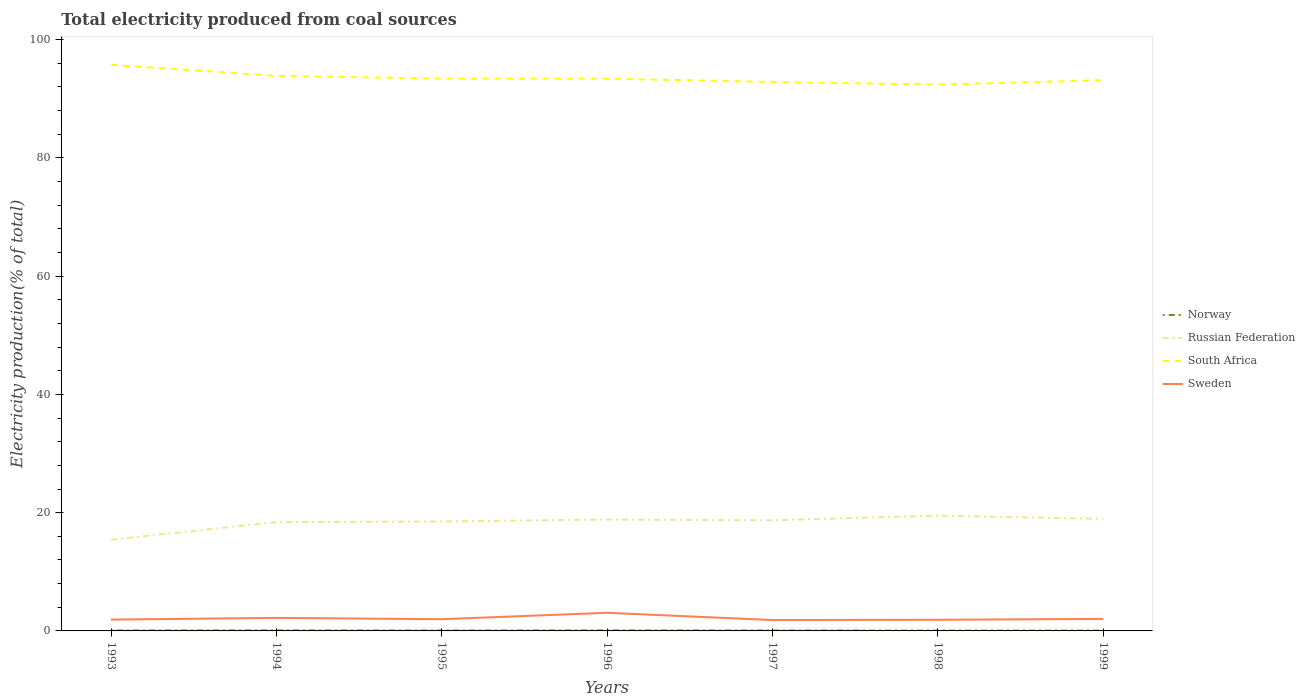How many different coloured lines are there?
Make the answer very short. 4. Does the line corresponding to Norway intersect with the line corresponding to Russian Federation?
Your response must be concise. No. Across all years, what is the maximum total electricity produced in Sweden?
Your answer should be compact. 1.84. What is the total total electricity produced in Russian Federation in the graph?
Your answer should be compact. -3.27. What is the difference between the highest and the second highest total electricity produced in South Africa?
Offer a terse response. 3.33. What is the difference between the highest and the lowest total electricity produced in South Africa?
Provide a short and direct response. 2. Is the total electricity produced in South Africa strictly greater than the total electricity produced in Sweden over the years?
Give a very brief answer. No. How many lines are there?
Give a very brief answer. 4. How many years are there in the graph?
Ensure brevity in your answer.  7. What is the difference between two consecutive major ticks on the Y-axis?
Provide a succinct answer. 20. Are the values on the major ticks of Y-axis written in scientific E-notation?
Ensure brevity in your answer.  No. Does the graph contain any zero values?
Give a very brief answer. No. Does the graph contain grids?
Your response must be concise. No. How are the legend labels stacked?
Provide a succinct answer. Vertical. What is the title of the graph?
Offer a very short reply. Total electricity produced from coal sources. Does "Sri Lanka" appear as one of the legend labels in the graph?
Offer a terse response. No. What is the label or title of the X-axis?
Provide a succinct answer. Years. What is the label or title of the Y-axis?
Give a very brief answer. Electricity production(% of total). What is the Electricity production(% of total) in Norway in 1993?
Ensure brevity in your answer.  0.07. What is the Electricity production(% of total) in Russian Federation in 1993?
Keep it short and to the point. 15.43. What is the Electricity production(% of total) of South Africa in 1993?
Offer a terse response. 95.73. What is the Electricity production(% of total) in Sweden in 1993?
Ensure brevity in your answer.  1.91. What is the Electricity production(% of total) of Norway in 1994?
Provide a succinct answer. 0.09. What is the Electricity production(% of total) in Russian Federation in 1994?
Give a very brief answer. 18.39. What is the Electricity production(% of total) of South Africa in 1994?
Your response must be concise. 93.86. What is the Electricity production(% of total) of Sweden in 1994?
Keep it short and to the point. 2.2. What is the Electricity production(% of total) in Norway in 1995?
Your response must be concise. 0.07. What is the Electricity production(% of total) in Russian Federation in 1995?
Give a very brief answer. 18.51. What is the Electricity production(% of total) of South Africa in 1995?
Give a very brief answer. 93.41. What is the Electricity production(% of total) in Sweden in 1995?
Your answer should be compact. 1.98. What is the Electricity production(% of total) in Norway in 1996?
Provide a succinct answer. 0.09. What is the Electricity production(% of total) in Russian Federation in 1996?
Make the answer very short. 18.83. What is the Electricity production(% of total) in South Africa in 1996?
Give a very brief answer. 93.41. What is the Electricity production(% of total) in Sweden in 1996?
Give a very brief answer. 3.07. What is the Electricity production(% of total) in Norway in 1997?
Make the answer very short. 0.07. What is the Electricity production(% of total) in Russian Federation in 1997?
Your answer should be very brief. 18.7. What is the Electricity production(% of total) in South Africa in 1997?
Make the answer very short. 92.84. What is the Electricity production(% of total) of Sweden in 1997?
Keep it short and to the point. 1.84. What is the Electricity production(% of total) in Norway in 1998?
Give a very brief answer. 0.07. What is the Electricity production(% of total) in Russian Federation in 1998?
Keep it short and to the point. 19.5. What is the Electricity production(% of total) in South Africa in 1998?
Ensure brevity in your answer.  92.4. What is the Electricity production(% of total) in Sweden in 1998?
Your answer should be compact. 1.88. What is the Electricity production(% of total) of Norway in 1999?
Give a very brief answer. 0.07. What is the Electricity production(% of total) of Russian Federation in 1999?
Your answer should be compact. 18.94. What is the Electricity production(% of total) in South Africa in 1999?
Your answer should be compact. 93.13. What is the Electricity production(% of total) of Sweden in 1999?
Give a very brief answer. 2.03. Across all years, what is the maximum Electricity production(% of total) in Norway?
Provide a short and direct response. 0.09. Across all years, what is the maximum Electricity production(% of total) of Russian Federation?
Make the answer very short. 19.5. Across all years, what is the maximum Electricity production(% of total) in South Africa?
Your answer should be very brief. 95.73. Across all years, what is the maximum Electricity production(% of total) in Sweden?
Make the answer very short. 3.07. Across all years, what is the minimum Electricity production(% of total) in Norway?
Keep it short and to the point. 0.07. Across all years, what is the minimum Electricity production(% of total) in Russian Federation?
Your response must be concise. 15.43. Across all years, what is the minimum Electricity production(% of total) in South Africa?
Offer a terse response. 92.4. Across all years, what is the minimum Electricity production(% of total) of Sweden?
Keep it short and to the point. 1.84. What is the total Electricity production(% of total) of Norway in the graph?
Offer a very short reply. 0.53. What is the total Electricity production(% of total) of Russian Federation in the graph?
Give a very brief answer. 128.31. What is the total Electricity production(% of total) of South Africa in the graph?
Give a very brief answer. 654.77. What is the total Electricity production(% of total) of Sweden in the graph?
Provide a short and direct response. 14.92. What is the difference between the Electricity production(% of total) in Norway in 1993 and that in 1994?
Provide a short and direct response. -0.01. What is the difference between the Electricity production(% of total) in Russian Federation in 1993 and that in 1994?
Offer a terse response. -2.96. What is the difference between the Electricity production(% of total) in South Africa in 1993 and that in 1994?
Offer a very short reply. 1.87. What is the difference between the Electricity production(% of total) of Sweden in 1993 and that in 1994?
Provide a succinct answer. -0.29. What is the difference between the Electricity production(% of total) of Norway in 1993 and that in 1995?
Provide a succinct answer. 0. What is the difference between the Electricity production(% of total) of Russian Federation in 1993 and that in 1995?
Your answer should be compact. -3.08. What is the difference between the Electricity production(% of total) in South Africa in 1993 and that in 1995?
Offer a very short reply. 2.32. What is the difference between the Electricity production(% of total) of Sweden in 1993 and that in 1995?
Your response must be concise. -0.07. What is the difference between the Electricity production(% of total) in Norway in 1993 and that in 1996?
Offer a very short reply. -0.01. What is the difference between the Electricity production(% of total) of Russian Federation in 1993 and that in 1996?
Keep it short and to the point. -3.4. What is the difference between the Electricity production(% of total) of South Africa in 1993 and that in 1996?
Offer a very short reply. 2.32. What is the difference between the Electricity production(% of total) of Sweden in 1993 and that in 1996?
Provide a succinct answer. -1.15. What is the difference between the Electricity production(% of total) in Norway in 1993 and that in 1997?
Keep it short and to the point. 0. What is the difference between the Electricity production(% of total) of Russian Federation in 1993 and that in 1997?
Make the answer very short. -3.27. What is the difference between the Electricity production(% of total) in South Africa in 1993 and that in 1997?
Offer a terse response. 2.9. What is the difference between the Electricity production(% of total) of Sweden in 1993 and that in 1997?
Provide a short and direct response. 0.07. What is the difference between the Electricity production(% of total) in Norway in 1993 and that in 1998?
Provide a short and direct response. 0.01. What is the difference between the Electricity production(% of total) of Russian Federation in 1993 and that in 1998?
Your response must be concise. -4.07. What is the difference between the Electricity production(% of total) of South Africa in 1993 and that in 1998?
Your response must be concise. 3.33. What is the difference between the Electricity production(% of total) of Sweden in 1993 and that in 1998?
Give a very brief answer. 0.03. What is the difference between the Electricity production(% of total) of Norway in 1993 and that in 1999?
Offer a terse response. 0.01. What is the difference between the Electricity production(% of total) in Russian Federation in 1993 and that in 1999?
Your answer should be compact. -3.51. What is the difference between the Electricity production(% of total) of South Africa in 1993 and that in 1999?
Keep it short and to the point. 2.6. What is the difference between the Electricity production(% of total) in Sweden in 1993 and that in 1999?
Ensure brevity in your answer.  -0.12. What is the difference between the Electricity production(% of total) of Norway in 1994 and that in 1995?
Keep it short and to the point. 0.02. What is the difference between the Electricity production(% of total) in Russian Federation in 1994 and that in 1995?
Your response must be concise. -0.12. What is the difference between the Electricity production(% of total) in South Africa in 1994 and that in 1995?
Provide a short and direct response. 0.45. What is the difference between the Electricity production(% of total) of Sweden in 1994 and that in 1995?
Make the answer very short. 0.22. What is the difference between the Electricity production(% of total) of Norway in 1994 and that in 1996?
Offer a terse response. 0. What is the difference between the Electricity production(% of total) in Russian Federation in 1994 and that in 1996?
Provide a succinct answer. -0.44. What is the difference between the Electricity production(% of total) in South Africa in 1994 and that in 1996?
Make the answer very short. 0.46. What is the difference between the Electricity production(% of total) in Sweden in 1994 and that in 1996?
Make the answer very short. -0.86. What is the difference between the Electricity production(% of total) of Norway in 1994 and that in 1997?
Ensure brevity in your answer.  0.02. What is the difference between the Electricity production(% of total) in Russian Federation in 1994 and that in 1997?
Provide a short and direct response. -0.31. What is the difference between the Electricity production(% of total) in South Africa in 1994 and that in 1997?
Your response must be concise. 1.03. What is the difference between the Electricity production(% of total) in Sweden in 1994 and that in 1997?
Ensure brevity in your answer.  0.37. What is the difference between the Electricity production(% of total) in Norway in 1994 and that in 1998?
Ensure brevity in your answer.  0.02. What is the difference between the Electricity production(% of total) of Russian Federation in 1994 and that in 1998?
Your response must be concise. -1.11. What is the difference between the Electricity production(% of total) in South Africa in 1994 and that in 1998?
Offer a very short reply. 1.46. What is the difference between the Electricity production(% of total) of Sweden in 1994 and that in 1998?
Provide a short and direct response. 0.32. What is the difference between the Electricity production(% of total) in Norway in 1994 and that in 1999?
Provide a succinct answer. 0.02. What is the difference between the Electricity production(% of total) of Russian Federation in 1994 and that in 1999?
Your response must be concise. -0.55. What is the difference between the Electricity production(% of total) in South Africa in 1994 and that in 1999?
Provide a succinct answer. 0.73. What is the difference between the Electricity production(% of total) in Sweden in 1994 and that in 1999?
Provide a short and direct response. 0.18. What is the difference between the Electricity production(% of total) of Norway in 1995 and that in 1996?
Provide a short and direct response. -0.02. What is the difference between the Electricity production(% of total) in Russian Federation in 1995 and that in 1996?
Provide a short and direct response. -0.32. What is the difference between the Electricity production(% of total) in South Africa in 1995 and that in 1996?
Your answer should be compact. 0. What is the difference between the Electricity production(% of total) of Sweden in 1995 and that in 1996?
Ensure brevity in your answer.  -1.08. What is the difference between the Electricity production(% of total) in Norway in 1995 and that in 1997?
Keep it short and to the point. -0. What is the difference between the Electricity production(% of total) of Russian Federation in 1995 and that in 1997?
Keep it short and to the point. -0.19. What is the difference between the Electricity production(% of total) of South Africa in 1995 and that in 1997?
Make the answer very short. 0.57. What is the difference between the Electricity production(% of total) in Sweden in 1995 and that in 1997?
Give a very brief answer. 0.14. What is the difference between the Electricity production(% of total) of Norway in 1995 and that in 1998?
Provide a short and direct response. 0. What is the difference between the Electricity production(% of total) of Russian Federation in 1995 and that in 1998?
Offer a very short reply. -0.99. What is the difference between the Electricity production(% of total) in South Africa in 1995 and that in 1998?
Your answer should be compact. 1.01. What is the difference between the Electricity production(% of total) in Sweden in 1995 and that in 1998?
Offer a terse response. 0.1. What is the difference between the Electricity production(% of total) in Norway in 1995 and that in 1999?
Offer a terse response. 0. What is the difference between the Electricity production(% of total) of Russian Federation in 1995 and that in 1999?
Your response must be concise. -0.43. What is the difference between the Electricity production(% of total) in South Africa in 1995 and that in 1999?
Your response must be concise. 0.27. What is the difference between the Electricity production(% of total) in Sweden in 1995 and that in 1999?
Offer a very short reply. -0.05. What is the difference between the Electricity production(% of total) of Norway in 1996 and that in 1997?
Offer a very short reply. 0.01. What is the difference between the Electricity production(% of total) in Russian Federation in 1996 and that in 1997?
Offer a terse response. 0.13. What is the difference between the Electricity production(% of total) in South Africa in 1996 and that in 1997?
Your answer should be very brief. 0.57. What is the difference between the Electricity production(% of total) of Sweden in 1996 and that in 1997?
Your answer should be very brief. 1.23. What is the difference between the Electricity production(% of total) of Norway in 1996 and that in 1998?
Your response must be concise. 0.02. What is the difference between the Electricity production(% of total) of Russian Federation in 1996 and that in 1998?
Your answer should be compact. -0.67. What is the difference between the Electricity production(% of total) of South Africa in 1996 and that in 1998?
Offer a terse response. 1.01. What is the difference between the Electricity production(% of total) of Sweden in 1996 and that in 1998?
Give a very brief answer. 1.18. What is the difference between the Electricity production(% of total) in Norway in 1996 and that in 1999?
Offer a terse response. 0.02. What is the difference between the Electricity production(% of total) of Russian Federation in 1996 and that in 1999?
Ensure brevity in your answer.  -0.11. What is the difference between the Electricity production(% of total) in South Africa in 1996 and that in 1999?
Ensure brevity in your answer.  0.27. What is the difference between the Electricity production(% of total) of Sweden in 1996 and that in 1999?
Your answer should be very brief. 1.04. What is the difference between the Electricity production(% of total) in Norway in 1997 and that in 1998?
Give a very brief answer. 0. What is the difference between the Electricity production(% of total) of Russian Federation in 1997 and that in 1998?
Offer a very short reply. -0.79. What is the difference between the Electricity production(% of total) of South Africa in 1997 and that in 1998?
Give a very brief answer. 0.44. What is the difference between the Electricity production(% of total) in Sweden in 1997 and that in 1998?
Your answer should be very brief. -0.05. What is the difference between the Electricity production(% of total) in Norway in 1997 and that in 1999?
Your response must be concise. 0. What is the difference between the Electricity production(% of total) in Russian Federation in 1997 and that in 1999?
Ensure brevity in your answer.  -0.24. What is the difference between the Electricity production(% of total) in South Africa in 1997 and that in 1999?
Your answer should be very brief. -0.3. What is the difference between the Electricity production(% of total) in Sweden in 1997 and that in 1999?
Keep it short and to the point. -0.19. What is the difference between the Electricity production(% of total) in Norway in 1998 and that in 1999?
Your response must be concise. -0. What is the difference between the Electricity production(% of total) in Russian Federation in 1998 and that in 1999?
Offer a very short reply. 0.55. What is the difference between the Electricity production(% of total) of South Africa in 1998 and that in 1999?
Offer a terse response. -0.74. What is the difference between the Electricity production(% of total) of Sweden in 1998 and that in 1999?
Your response must be concise. -0.14. What is the difference between the Electricity production(% of total) of Norway in 1993 and the Electricity production(% of total) of Russian Federation in 1994?
Provide a short and direct response. -18.32. What is the difference between the Electricity production(% of total) of Norway in 1993 and the Electricity production(% of total) of South Africa in 1994?
Your answer should be very brief. -93.79. What is the difference between the Electricity production(% of total) in Norway in 1993 and the Electricity production(% of total) in Sweden in 1994?
Make the answer very short. -2.13. What is the difference between the Electricity production(% of total) in Russian Federation in 1993 and the Electricity production(% of total) in South Africa in 1994?
Make the answer very short. -78.43. What is the difference between the Electricity production(% of total) in Russian Federation in 1993 and the Electricity production(% of total) in Sweden in 1994?
Ensure brevity in your answer.  13.23. What is the difference between the Electricity production(% of total) of South Africa in 1993 and the Electricity production(% of total) of Sweden in 1994?
Provide a short and direct response. 93.53. What is the difference between the Electricity production(% of total) of Norway in 1993 and the Electricity production(% of total) of Russian Federation in 1995?
Give a very brief answer. -18.44. What is the difference between the Electricity production(% of total) of Norway in 1993 and the Electricity production(% of total) of South Africa in 1995?
Offer a very short reply. -93.33. What is the difference between the Electricity production(% of total) in Norway in 1993 and the Electricity production(% of total) in Sweden in 1995?
Give a very brief answer. -1.91. What is the difference between the Electricity production(% of total) in Russian Federation in 1993 and the Electricity production(% of total) in South Africa in 1995?
Make the answer very short. -77.97. What is the difference between the Electricity production(% of total) in Russian Federation in 1993 and the Electricity production(% of total) in Sweden in 1995?
Give a very brief answer. 13.45. What is the difference between the Electricity production(% of total) in South Africa in 1993 and the Electricity production(% of total) in Sweden in 1995?
Your answer should be very brief. 93.75. What is the difference between the Electricity production(% of total) of Norway in 1993 and the Electricity production(% of total) of Russian Federation in 1996?
Your answer should be very brief. -18.76. What is the difference between the Electricity production(% of total) of Norway in 1993 and the Electricity production(% of total) of South Africa in 1996?
Make the answer very short. -93.33. What is the difference between the Electricity production(% of total) in Norway in 1993 and the Electricity production(% of total) in Sweden in 1996?
Your answer should be very brief. -2.99. What is the difference between the Electricity production(% of total) of Russian Federation in 1993 and the Electricity production(% of total) of South Africa in 1996?
Provide a short and direct response. -77.97. What is the difference between the Electricity production(% of total) in Russian Federation in 1993 and the Electricity production(% of total) in Sweden in 1996?
Provide a short and direct response. 12.37. What is the difference between the Electricity production(% of total) in South Africa in 1993 and the Electricity production(% of total) in Sweden in 1996?
Your answer should be very brief. 92.66. What is the difference between the Electricity production(% of total) in Norway in 1993 and the Electricity production(% of total) in Russian Federation in 1997?
Your answer should be compact. -18.63. What is the difference between the Electricity production(% of total) in Norway in 1993 and the Electricity production(% of total) in South Africa in 1997?
Offer a terse response. -92.76. What is the difference between the Electricity production(% of total) of Norway in 1993 and the Electricity production(% of total) of Sweden in 1997?
Make the answer very short. -1.76. What is the difference between the Electricity production(% of total) in Russian Federation in 1993 and the Electricity production(% of total) in South Africa in 1997?
Make the answer very short. -77.4. What is the difference between the Electricity production(% of total) of Russian Federation in 1993 and the Electricity production(% of total) of Sweden in 1997?
Offer a very short reply. 13.59. What is the difference between the Electricity production(% of total) of South Africa in 1993 and the Electricity production(% of total) of Sweden in 1997?
Offer a very short reply. 93.89. What is the difference between the Electricity production(% of total) in Norway in 1993 and the Electricity production(% of total) in Russian Federation in 1998?
Provide a short and direct response. -19.42. What is the difference between the Electricity production(% of total) of Norway in 1993 and the Electricity production(% of total) of South Africa in 1998?
Give a very brief answer. -92.32. What is the difference between the Electricity production(% of total) of Norway in 1993 and the Electricity production(% of total) of Sweden in 1998?
Your response must be concise. -1.81. What is the difference between the Electricity production(% of total) of Russian Federation in 1993 and the Electricity production(% of total) of South Africa in 1998?
Your answer should be compact. -76.97. What is the difference between the Electricity production(% of total) in Russian Federation in 1993 and the Electricity production(% of total) in Sweden in 1998?
Your answer should be very brief. 13.55. What is the difference between the Electricity production(% of total) in South Africa in 1993 and the Electricity production(% of total) in Sweden in 1998?
Offer a terse response. 93.85. What is the difference between the Electricity production(% of total) in Norway in 1993 and the Electricity production(% of total) in Russian Federation in 1999?
Provide a short and direct response. -18.87. What is the difference between the Electricity production(% of total) of Norway in 1993 and the Electricity production(% of total) of South Africa in 1999?
Your answer should be compact. -93.06. What is the difference between the Electricity production(% of total) in Norway in 1993 and the Electricity production(% of total) in Sweden in 1999?
Provide a short and direct response. -1.95. What is the difference between the Electricity production(% of total) of Russian Federation in 1993 and the Electricity production(% of total) of South Africa in 1999?
Your answer should be compact. -77.7. What is the difference between the Electricity production(% of total) in Russian Federation in 1993 and the Electricity production(% of total) in Sweden in 1999?
Give a very brief answer. 13.4. What is the difference between the Electricity production(% of total) of South Africa in 1993 and the Electricity production(% of total) of Sweden in 1999?
Your answer should be compact. 93.7. What is the difference between the Electricity production(% of total) of Norway in 1994 and the Electricity production(% of total) of Russian Federation in 1995?
Offer a very short reply. -18.42. What is the difference between the Electricity production(% of total) of Norway in 1994 and the Electricity production(% of total) of South Africa in 1995?
Offer a terse response. -93.32. What is the difference between the Electricity production(% of total) of Norway in 1994 and the Electricity production(% of total) of Sweden in 1995?
Offer a very short reply. -1.89. What is the difference between the Electricity production(% of total) in Russian Federation in 1994 and the Electricity production(% of total) in South Africa in 1995?
Provide a succinct answer. -75.02. What is the difference between the Electricity production(% of total) of Russian Federation in 1994 and the Electricity production(% of total) of Sweden in 1995?
Ensure brevity in your answer.  16.41. What is the difference between the Electricity production(% of total) in South Africa in 1994 and the Electricity production(% of total) in Sweden in 1995?
Make the answer very short. 91.88. What is the difference between the Electricity production(% of total) in Norway in 1994 and the Electricity production(% of total) in Russian Federation in 1996?
Provide a succinct answer. -18.74. What is the difference between the Electricity production(% of total) in Norway in 1994 and the Electricity production(% of total) in South Africa in 1996?
Your answer should be very brief. -93.32. What is the difference between the Electricity production(% of total) in Norway in 1994 and the Electricity production(% of total) in Sweden in 1996?
Ensure brevity in your answer.  -2.98. What is the difference between the Electricity production(% of total) in Russian Federation in 1994 and the Electricity production(% of total) in South Africa in 1996?
Provide a short and direct response. -75.02. What is the difference between the Electricity production(% of total) in Russian Federation in 1994 and the Electricity production(% of total) in Sweden in 1996?
Provide a succinct answer. 15.32. What is the difference between the Electricity production(% of total) of South Africa in 1994 and the Electricity production(% of total) of Sweden in 1996?
Provide a succinct answer. 90.8. What is the difference between the Electricity production(% of total) in Norway in 1994 and the Electricity production(% of total) in Russian Federation in 1997?
Provide a short and direct response. -18.62. What is the difference between the Electricity production(% of total) in Norway in 1994 and the Electricity production(% of total) in South Africa in 1997?
Your answer should be compact. -92.75. What is the difference between the Electricity production(% of total) of Norway in 1994 and the Electricity production(% of total) of Sweden in 1997?
Your response must be concise. -1.75. What is the difference between the Electricity production(% of total) in Russian Federation in 1994 and the Electricity production(% of total) in South Africa in 1997?
Provide a short and direct response. -74.44. What is the difference between the Electricity production(% of total) in Russian Federation in 1994 and the Electricity production(% of total) in Sweden in 1997?
Give a very brief answer. 16.55. What is the difference between the Electricity production(% of total) in South Africa in 1994 and the Electricity production(% of total) in Sweden in 1997?
Provide a short and direct response. 92.02. What is the difference between the Electricity production(% of total) of Norway in 1994 and the Electricity production(% of total) of Russian Federation in 1998?
Give a very brief answer. -19.41. What is the difference between the Electricity production(% of total) in Norway in 1994 and the Electricity production(% of total) in South Africa in 1998?
Provide a short and direct response. -92.31. What is the difference between the Electricity production(% of total) of Norway in 1994 and the Electricity production(% of total) of Sweden in 1998?
Make the answer very short. -1.8. What is the difference between the Electricity production(% of total) of Russian Federation in 1994 and the Electricity production(% of total) of South Africa in 1998?
Provide a short and direct response. -74.01. What is the difference between the Electricity production(% of total) in Russian Federation in 1994 and the Electricity production(% of total) in Sweden in 1998?
Your answer should be compact. 16.51. What is the difference between the Electricity production(% of total) of South Africa in 1994 and the Electricity production(% of total) of Sweden in 1998?
Your response must be concise. 91.98. What is the difference between the Electricity production(% of total) of Norway in 1994 and the Electricity production(% of total) of Russian Federation in 1999?
Provide a short and direct response. -18.86. What is the difference between the Electricity production(% of total) of Norway in 1994 and the Electricity production(% of total) of South Africa in 1999?
Ensure brevity in your answer.  -93.05. What is the difference between the Electricity production(% of total) of Norway in 1994 and the Electricity production(% of total) of Sweden in 1999?
Make the answer very short. -1.94. What is the difference between the Electricity production(% of total) in Russian Federation in 1994 and the Electricity production(% of total) in South Africa in 1999?
Give a very brief answer. -74.74. What is the difference between the Electricity production(% of total) of Russian Federation in 1994 and the Electricity production(% of total) of Sweden in 1999?
Make the answer very short. 16.36. What is the difference between the Electricity production(% of total) in South Africa in 1994 and the Electricity production(% of total) in Sweden in 1999?
Ensure brevity in your answer.  91.83. What is the difference between the Electricity production(% of total) in Norway in 1995 and the Electricity production(% of total) in Russian Federation in 1996?
Ensure brevity in your answer.  -18.76. What is the difference between the Electricity production(% of total) in Norway in 1995 and the Electricity production(% of total) in South Africa in 1996?
Give a very brief answer. -93.34. What is the difference between the Electricity production(% of total) in Norway in 1995 and the Electricity production(% of total) in Sweden in 1996?
Offer a very short reply. -3. What is the difference between the Electricity production(% of total) in Russian Federation in 1995 and the Electricity production(% of total) in South Africa in 1996?
Keep it short and to the point. -74.89. What is the difference between the Electricity production(% of total) of Russian Federation in 1995 and the Electricity production(% of total) of Sweden in 1996?
Give a very brief answer. 15.45. What is the difference between the Electricity production(% of total) of South Africa in 1995 and the Electricity production(% of total) of Sweden in 1996?
Ensure brevity in your answer.  90.34. What is the difference between the Electricity production(% of total) of Norway in 1995 and the Electricity production(% of total) of Russian Federation in 1997?
Your answer should be compact. -18.63. What is the difference between the Electricity production(% of total) of Norway in 1995 and the Electricity production(% of total) of South Africa in 1997?
Provide a short and direct response. -92.77. What is the difference between the Electricity production(% of total) of Norway in 1995 and the Electricity production(% of total) of Sweden in 1997?
Provide a short and direct response. -1.77. What is the difference between the Electricity production(% of total) of Russian Federation in 1995 and the Electricity production(% of total) of South Africa in 1997?
Your answer should be very brief. -74.32. What is the difference between the Electricity production(% of total) in Russian Federation in 1995 and the Electricity production(% of total) in Sweden in 1997?
Offer a very short reply. 16.67. What is the difference between the Electricity production(% of total) of South Africa in 1995 and the Electricity production(% of total) of Sweden in 1997?
Keep it short and to the point. 91.57. What is the difference between the Electricity production(% of total) in Norway in 1995 and the Electricity production(% of total) in Russian Federation in 1998?
Ensure brevity in your answer.  -19.43. What is the difference between the Electricity production(% of total) of Norway in 1995 and the Electricity production(% of total) of South Africa in 1998?
Offer a terse response. -92.33. What is the difference between the Electricity production(% of total) in Norway in 1995 and the Electricity production(% of total) in Sweden in 1998?
Your answer should be very brief. -1.81. What is the difference between the Electricity production(% of total) in Russian Federation in 1995 and the Electricity production(% of total) in South Africa in 1998?
Give a very brief answer. -73.89. What is the difference between the Electricity production(% of total) in Russian Federation in 1995 and the Electricity production(% of total) in Sweden in 1998?
Your answer should be compact. 16.63. What is the difference between the Electricity production(% of total) of South Africa in 1995 and the Electricity production(% of total) of Sweden in 1998?
Your response must be concise. 91.52. What is the difference between the Electricity production(% of total) in Norway in 1995 and the Electricity production(% of total) in Russian Federation in 1999?
Make the answer very short. -18.88. What is the difference between the Electricity production(% of total) of Norway in 1995 and the Electricity production(% of total) of South Africa in 1999?
Ensure brevity in your answer.  -93.06. What is the difference between the Electricity production(% of total) of Norway in 1995 and the Electricity production(% of total) of Sweden in 1999?
Offer a terse response. -1.96. What is the difference between the Electricity production(% of total) of Russian Federation in 1995 and the Electricity production(% of total) of South Africa in 1999?
Make the answer very short. -74.62. What is the difference between the Electricity production(% of total) in Russian Federation in 1995 and the Electricity production(% of total) in Sweden in 1999?
Offer a very short reply. 16.48. What is the difference between the Electricity production(% of total) in South Africa in 1995 and the Electricity production(% of total) in Sweden in 1999?
Your answer should be very brief. 91.38. What is the difference between the Electricity production(% of total) in Norway in 1996 and the Electricity production(% of total) in Russian Federation in 1997?
Provide a succinct answer. -18.62. What is the difference between the Electricity production(% of total) of Norway in 1996 and the Electricity production(% of total) of South Africa in 1997?
Give a very brief answer. -92.75. What is the difference between the Electricity production(% of total) of Norway in 1996 and the Electricity production(% of total) of Sweden in 1997?
Ensure brevity in your answer.  -1.75. What is the difference between the Electricity production(% of total) of Russian Federation in 1996 and the Electricity production(% of total) of South Africa in 1997?
Offer a terse response. -74. What is the difference between the Electricity production(% of total) in Russian Federation in 1996 and the Electricity production(% of total) in Sweden in 1997?
Your answer should be compact. 16.99. What is the difference between the Electricity production(% of total) in South Africa in 1996 and the Electricity production(% of total) in Sweden in 1997?
Your answer should be compact. 91.57. What is the difference between the Electricity production(% of total) of Norway in 1996 and the Electricity production(% of total) of Russian Federation in 1998?
Make the answer very short. -19.41. What is the difference between the Electricity production(% of total) of Norway in 1996 and the Electricity production(% of total) of South Africa in 1998?
Your answer should be very brief. -92.31. What is the difference between the Electricity production(% of total) in Norway in 1996 and the Electricity production(% of total) in Sweden in 1998?
Provide a short and direct response. -1.8. What is the difference between the Electricity production(% of total) of Russian Federation in 1996 and the Electricity production(% of total) of South Africa in 1998?
Offer a very short reply. -73.57. What is the difference between the Electricity production(% of total) in Russian Federation in 1996 and the Electricity production(% of total) in Sweden in 1998?
Provide a short and direct response. 16.95. What is the difference between the Electricity production(% of total) in South Africa in 1996 and the Electricity production(% of total) in Sweden in 1998?
Your response must be concise. 91.52. What is the difference between the Electricity production(% of total) of Norway in 1996 and the Electricity production(% of total) of Russian Federation in 1999?
Give a very brief answer. -18.86. What is the difference between the Electricity production(% of total) in Norway in 1996 and the Electricity production(% of total) in South Africa in 1999?
Your answer should be very brief. -93.05. What is the difference between the Electricity production(% of total) of Norway in 1996 and the Electricity production(% of total) of Sweden in 1999?
Ensure brevity in your answer.  -1.94. What is the difference between the Electricity production(% of total) of Russian Federation in 1996 and the Electricity production(% of total) of South Africa in 1999?
Offer a terse response. -74.3. What is the difference between the Electricity production(% of total) in Russian Federation in 1996 and the Electricity production(% of total) in Sweden in 1999?
Offer a terse response. 16.8. What is the difference between the Electricity production(% of total) of South Africa in 1996 and the Electricity production(% of total) of Sweden in 1999?
Offer a very short reply. 91.38. What is the difference between the Electricity production(% of total) of Norway in 1997 and the Electricity production(% of total) of Russian Federation in 1998?
Keep it short and to the point. -19.43. What is the difference between the Electricity production(% of total) in Norway in 1997 and the Electricity production(% of total) in South Africa in 1998?
Provide a short and direct response. -92.33. What is the difference between the Electricity production(% of total) in Norway in 1997 and the Electricity production(% of total) in Sweden in 1998?
Provide a succinct answer. -1.81. What is the difference between the Electricity production(% of total) of Russian Federation in 1997 and the Electricity production(% of total) of South Africa in 1998?
Your answer should be very brief. -73.69. What is the difference between the Electricity production(% of total) in Russian Federation in 1997 and the Electricity production(% of total) in Sweden in 1998?
Ensure brevity in your answer.  16.82. What is the difference between the Electricity production(% of total) in South Africa in 1997 and the Electricity production(% of total) in Sweden in 1998?
Give a very brief answer. 90.95. What is the difference between the Electricity production(% of total) in Norway in 1997 and the Electricity production(% of total) in Russian Federation in 1999?
Keep it short and to the point. -18.87. What is the difference between the Electricity production(% of total) in Norway in 1997 and the Electricity production(% of total) in South Africa in 1999?
Your answer should be compact. -93.06. What is the difference between the Electricity production(% of total) in Norway in 1997 and the Electricity production(% of total) in Sweden in 1999?
Offer a terse response. -1.96. What is the difference between the Electricity production(% of total) in Russian Federation in 1997 and the Electricity production(% of total) in South Africa in 1999?
Your answer should be compact. -74.43. What is the difference between the Electricity production(% of total) of Russian Federation in 1997 and the Electricity production(% of total) of Sweden in 1999?
Make the answer very short. 16.68. What is the difference between the Electricity production(% of total) in South Africa in 1997 and the Electricity production(% of total) in Sweden in 1999?
Your answer should be very brief. 90.81. What is the difference between the Electricity production(% of total) of Norway in 1998 and the Electricity production(% of total) of Russian Federation in 1999?
Ensure brevity in your answer.  -18.88. What is the difference between the Electricity production(% of total) of Norway in 1998 and the Electricity production(% of total) of South Africa in 1999?
Make the answer very short. -93.07. What is the difference between the Electricity production(% of total) of Norway in 1998 and the Electricity production(% of total) of Sweden in 1999?
Offer a very short reply. -1.96. What is the difference between the Electricity production(% of total) of Russian Federation in 1998 and the Electricity production(% of total) of South Africa in 1999?
Keep it short and to the point. -73.64. What is the difference between the Electricity production(% of total) of Russian Federation in 1998 and the Electricity production(% of total) of Sweden in 1999?
Offer a terse response. 17.47. What is the difference between the Electricity production(% of total) of South Africa in 1998 and the Electricity production(% of total) of Sweden in 1999?
Offer a very short reply. 90.37. What is the average Electricity production(% of total) in Norway per year?
Ensure brevity in your answer.  0.08. What is the average Electricity production(% of total) in Russian Federation per year?
Offer a terse response. 18.33. What is the average Electricity production(% of total) in South Africa per year?
Offer a very short reply. 93.54. What is the average Electricity production(% of total) in Sweden per year?
Your response must be concise. 2.13. In the year 1993, what is the difference between the Electricity production(% of total) in Norway and Electricity production(% of total) in Russian Federation?
Give a very brief answer. -15.36. In the year 1993, what is the difference between the Electricity production(% of total) in Norway and Electricity production(% of total) in South Africa?
Offer a terse response. -95.66. In the year 1993, what is the difference between the Electricity production(% of total) of Norway and Electricity production(% of total) of Sweden?
Offer a terse response. -1.84. In the year 1993, what is the difference between the Electricity production(% of total) of Russian Federation and Electricity production(% of total) of South Africa?
Your response must be concise. -80.3. In the year 1993, what is the difference between the Electricity production(% of total) in Russian Federation and Electricity production(% of total) in Sweden?
Make the answer very short. 13.52. In the year 1993, what is the difference between the Electricity production(% of total) of South Africa and Electricity production(% of total) of Sweden?
Offer a very short reply. 93.82. In the year 1994, what is the difference between the Electricity production(% of total) in Norway and Electricity production(% of total) in Russian Federation?
Keep it short and to the point. -18.3. In the year 1994, what is the difference between the Electricity production(% of total) of Norway and Electricity production(% of total) of South Africa?
Keep it short and to the point. -93.77. In the year 1994, what is the difference between the Electricity production(% of total) in Norway and Electricity production(% of total) in Sweden?
Provide a succinct answer. -2.12. In the year 1994, what is the difference between the Electricity production(% of total) of Russian Federation and Electricity production(% of total) of South Africa?
Your response must be concise. -75.47. In the year 1994, what is the difference between the Electricity production(% of total) of Russian Federation and Electricity production(% of total) of Sweden?
Offer a terse response. 16.19. In the year 1994, what is the difference between the Electricity production(% of total) of South Africa and Electricity production(% of total) of Sweden?
Make the answer very short. 91.66. In the year 1995, what is the difference between the Electricity production(% of total) of Norway and Electricity production(% of total) of Russian Federation?
Give a very brief answer. -18.44. In the year 1995, what is the difference between the Electricity production(% of total) of Norway and Electricity production(% of total) of South Africa?
Make the answer very short. -93.34. In the year 1995, what is the difference between the Electricity production(% of total) in Norway and Electricity production(% of total) in Sweden?
Keep it short and to the point. -1.91. In the year 1995, what is the difference between the Electricity production(% of total) of Russian Federation and Electricity production(% of total) of South Africa?
Provide a short and direct response. -74.9. In the year 1995, what is the difference between the Electricity production(% of total) of Russian Federation and Electricity production(% of total) of Sweden?
Your answer should be very brief. 16.53. In the year 1995, what is the difference between the Electricity production(% of total) of South Africa and Electricity production(% of total) of Sweden?
Ensure brevity in your answer.  91.43. In the year 1996, what is the difference between the Electricity production(% of total) in Norway and Electricity production(% of total) in Russian Federation?
Your answer should be compact. -18.74. In the year 1996, what is the difference between the Electricity production(% of total) of Norway and Electricity production(% of total) of South Africa?
Give a very brief answer. -93.32. In the year 1996, what is the difference between the Electricity production(% of total) in Norway and Electricity production(% of total) in Sweden?
Provide a short and direct response. -2.98. In the year 1996, what is the difference between the Electricity production(% of total) of Russian Federation and Electricity production(% of total) of South Africa?
Ensure brevity in your answer.  -74.58. In the year 1996, what is the difference between the Electricity production(% of total) of Russian Federation and Electricity production(% of total) of Sweden?
Provide a succinct answer. 15.76. In the year 1996, what is the difference between the Electricity production(% of total) of South Africa and Electricity production(% of total) of Sweden?
Your answer should be compact. 90.34. In the year 1997, what is the difference between the Electricity production(% of total) in Norway and Electricity production(% of total) in Russian Federation?
Your response must be concise. -18.63. In the year 1997, what is the difference between the Electricity production(% of total) of Norway and Electricity production(% of total) of South Africa?
Offer a terse response. -92.76. In the year 1997, what is the difference between the Electricity production(% of total) in Norway and Electricity production(% of total) in Sweden?
Ensure brevity in your answer.  -1.77. In the year 1997, what is the difference between the Electricity production(% of total) of Russian Federation and Electricity production(% of total) of South Africa?
Provide a short and direct response. -74.13. In the year 1997, what is the difference between the Electricity production(% of total) of Russian Federation and Electricity production(% of total) of Sweden?
Offer a very short reply. 16.87. In the year 1997, what is the difference between the Electricity production(% of total) in South Africa and Electricity production(% of total) in Sweden?
Give a very brief answer. 91. In the year 1998, what is the difference between the Electricity production(% of total) of Norway and Electricity production(% of total) of Russian Federation?
Give a very brief answer. -19.43. In the year 1998, what is the difference between the Electricity production(% of total) of Norway and Electricity production(% of total) of South Africa?
Your answer should be compact. -92.33. In the year 1998, what is the difference between the Electricity production(% of total) of Norway and Electricity production(% of total) of Sweden?
Offer a very short reply. -1.82. In the year 1998, what is the difference between the Electricity production(% of total) of Russian Federation and Electricity production(% of total) of South Africa?
Your answer should be very brief. -72.9. In the year 1998, what is the difference between the Electricity production(% of total) of Russian Federation and Electricity production(% of total) of Sweden?
Provide a short and direct response. 17.62. In the year 1998, what is the difference between the Electricity production(% of total) in South Africa and Electricity production(% of total) in Sweden?
Your answer should be very brief. 90.52. In the year 1999, what is the difference between the Electricity production(% of total) in Norway and Electricity production(% of total) in Russian Federation?
Make the answer very short. -18.88. In the year 1999, what is the difference between the Electricity production(% of total) in Norway and Electricity production(% of total) in South Africa?
Your answer should be compact. -93.07. In the year 1999, what is the difference between the Electricity production(% of total) of Norway and Electricity production(% of total) of Sweden?
Keep it short and to the point. -1.96. In the year 1999, what is the difference between the Electricity production(% of total) of Russian Federation and Electricity production(% of total) of South Africa?
Ensure brevity in your answer.  -74.19. In the year 1999, what is the difference between the Electricity production(% of total) in Russian Federation and Electricity production(% of total) in Sweden?
Offer a terse response. 16.92. In the year 1999, what is the difference between the Electricity production(% of total) in South Africa and Electricity production(% of total) in Sweden?
Offer a very short reply. 91.11. What is the ratio of the Electricity production(% of total) in Norway in 1993 to that in 1994?
Offer a terse response. 0.84. What is the ratio of the Electricity production(% of total) in Russian Federation in 1993 to that in 1994?
Ensure brevity in your answer.  0.84. What is the ratio of the Electricity production(% of total) of South Africa in 1993 to that in 1994?
Keep it short and to the point. 1.02. What is the ratio of the Electricity production(% of total) in Sweden in 1993 to that in 1994?
Your answer should be very brief. 0.87. What is the ratio of the Electricity production(% of total) in Norway in 1993 to that in 1995?
Provide a succinct answer. 1.07. What is the ratio of the Electricity production(% of total) of Russian Federation in 1993 to that in 1995?
Provide a short and direct response. 0.83. What is the ratio of the Electricity production(% of total) of South Africa in 1993 to that in 1995?
Provide a succinct answer. 1.02. What is the ratio of the Electricity production(% of total) in Sweden in 1993 to that in 1995?
Offer a very short reply. 0.96. What is the ratio of the Electricity production(% of total) in Norway in 1993 to that in 1996?
Your answer should be compact. 0.86. What is the ratio of the Electricity production(% of total) in Russian Federation in 1993 to that in 1996?
Give a very brief answer. 0.82. What is the ratio of the Electricity production(% of total) in South Africa in 1993 to that in 1996?
Offer a very short reply. 1.02. What is the ratio of the Electricity production(% of total) in Sweden in 1993 to that in 1996?
Provide a short and direct response. 0.62. What is the ratio of the Electricity production(% of total) of Norway in 1993 to that in 1997?
Your response must be concise. 1.03. What is the ratio of the Electricity production(% of total) in Russian Federation in 1993 to that in 1997?
Ensure brevity in your answer.  0.83. What is the ratio of the Electricity production(% of total) of South Africa in 1993 to that in 1997?
Your response must be concise. 1.03. What is the ratio of the Electricity production(% of total) of Sweden in 1993 to that in 1997?
Your answer should be compact. 1.04. What is the ratio of the Electricity production(% of total) in Norway in 1993 to that in 1998?
Your answer should be very brief. 1.1. What is the ratio of the Electricity production(% of total) of Russian Federation in 1993 to that in 1998?
Your answer should be compact. 0.79. What is the ratio of the Electricity production(% of total) in South Africa in 1993 to that in 1998?
Give a very brief answer. 1.04. What is the ratio of the Electricity production(% of total) of Sweden in 1993 to that in 1998?
Keep it short and to the point. 1.02. What is the ratio of the Electricity production(% of total) of Norway in 1993 to that in 1999?
Give a very brief answer. 1.1. What is the ratio of the Electricity production(% of total) of Russian Federation in 1993 to that in 1999?
Your answer should be compact. 0.81. What is the ratio of the Electricity production(% of total) of South Africa in 1993 to that in 1999?
Provide a succinct answer. 1.03. What is the ratio of the Electricity production(% of total) in Sweden in 1993 to that in 1999?
Offer a terse response. 0.94. What is the ratio of the Electricity production(% of total) in Norway in 1994 to that in 1995?
Keep it short and to the point. 1.27. What is the ratio of the Electricity production(% of total) in South Africa in 1994 to that in 1995?
Offer a very short reply. 1. What is the ratio of the Electricity production(% of total) in Sweden in 1994 to that in 1995?
Your answer should be very brief. 1.11. What is the ratio of the Electricity production(% of total) of Norway in 1994 to that in 1996?
Provide a succinct answer. 1.01. What is the ratio of the Electricity production(% of total) in Russian Federation in 1994 to that in 1996?
Offer a very short reply. 0.98. What is the ratio of the Electricity production(% of total) of South Africa in 1994 to that in 1996?
Your answer should be very brief. 1. What is the ratio of the Electricity production(% of total) of Sweden in 1994 to that in 1996?
Your response must be concise. 0.72. What is the ratio of the Electricity production(% of total) in Norway in 1994 to that in 1997?
Make the answer very short. 1.22. What is the ratio of the Electricity production(% of total) in Russian Federation in 1994 to that in 1997?
Your answer should be compact. 0.98. What is the ratio of the Electricity production(% of total) in South Africa in 1994 to that in 1997?
Offer a very short reply. 1.01. What is the ratio of the Electricity production(% of total) in Sweden in 1994 to that in 1997?
Your answer should be compact. 1.2. What is the ratio of the Electricity production(% of total) in Norway in 1994 to that in 1998?
Give a very brief answer. 1.3. What is the ratio of the Electricity production(% of total) in Russian Federation in 1994 to that in 1998?
Provide a short and direct response. 0.94. What is the ratio of the Electricity production(% of total) of South Africa in 1994 to that in 1998?
Give a very brief answer. 1.02. What is the ratio of the Electricity production(% of total) of Sweden in 1994 to that in 1998?
Keep it short and to the point. 1.17. What is the ratio of the Electricity production(% of total) in Norway in 1994 to that in 1999?
Give a very brief answer. 1.3. What is the ratio of the Electricity production(% of total) in Russian Federation in 1994 to that in 1999?
Provide a short and direct response. 0.97. What is the ratio of the Electricity production(% of total) in Sweden in 1994 to that in 1999?
Offer a very short reply. 1.09. What is the ratio of the Electricity production(% of total) of Russian Federation in 1995 to that in 1996?
Your answer should be compact. 0.98. What is the ratio of the Electricity production(% of total) of South Africa in 1995 to that in 1996?
Provide a succinct answer. 1. What is the ratio of the Electricity production(% of total) in Sweden in 1995 to that in 1996?
Give a very brief answer. 0.65. What is the ratio of the Electricity production(% of total) of Norway in 1995 to that in 1997?
Your answer should be compact. 0.96. What is the ratio of the Electricity production(% of total) of Russian Federation in 1995 to that in 1997?
Offer a terse response. 0.99. What is the ratio of the Electricity production(% of total) of Sweden in 1995 to that in 1997?
Give a very brief answer. 1.08. What is the ratio of the Electricity production(% of total) in Norway in 1995 to that in 1998?
Provide a short and direct response. 1.02. What is the ratio of the Electricity production(% of total) of Russian Federation in 1995 to that in 1998?
Your response must be concise. 0.95. What is the ratio of the Electricity production(% of total) in South Africa in 1995 to that in 1998?
Give a very brief answer. 1.01. What is the ratio of the Electricity production(% of total) in Sweden in 1995 to that in 1998?
Provide a short and direct response. 1.05. What is the ratio of the Electricity production(% of total) of Norway in 1995 to that in 1999?
Keep it short and to the point. 1.02. What is the ratio of the Electricity production(% of total) in Russian Federation in 1995 to that in 1999?
Provide a short and direct response. 0.98. What is the ratio of the Electricity production(% of total) in Sweden in 1995 to that in 1999?
Your answer should be very brief. 0.98. What is the ratio of the Electricity production(% of total) in Norway in 1996 to that in 1997?
Your answer should be very brief. 1.2. What is the ratio of the Electricity production(% of total) in Russian Federation in 1996 to that in 1997?
Provide a succinct answer. 1.01. What is the ratio of the Electricity production(% of total) of South Africa in 1996 to that in 1997?
Make the answer very short. 1.01. What is the ratio of the Electricity production(% of total) of Sweden in 1996 to that in 1997?
Keep it short and to the point. 1.67. What is the ratio of the Electricity production(% of total) of Norway in 1996 to that in 1998?
Offer a very short reply. 1.28. What is the ratio of the Electricity production(% of total) of Russian Federation in 1996 to that in 1998?
Provide a succinct answer. 0.97. What is the ratio of the Electricity production(% of total) in South Africa in 1996 to that in 1998?
Your answer should be very brief. 1.01. What is the ratio of the Electricity production(% of total) of Sweden in 1996 to that in 1998?
Your answer should be compact. 1.63. What is the ratio of the Electricity production(% of total) of Norway in 1996 to that in 1999?
Offer a very short reply. 1.28. What is the ratio of the Electricity production(% of total) of South Africa in 1996 to that in 1999?
Your answer should be compact. 1. What is the ratio of the Electricity production(% of total) of Sweden in 1996 to that in 1999?
Provide a succinct answer. 1.51. What is the ratio of the Electricity production(% of total) in Norway in 1997 to that in 1998?
Give a very brief answer. 1.07. What is the ratio of the Electricity production(% of total) in Russian Federation in 1997 to that in 1998?
Provide a succinct answer. 0.96. What is the ratio of the Electricity production(% of total) of Sweden in 1997 to that in 1998?
Provide a succinct answer. 0.98. What is the ratio of the Electricity production(% of total) of Norway in 1997 to that in 1999?
Your answer should be very brief. 1.07. What is the ratio of the Electricity production(% of total) in Russian Federation in 1997 to that in 1999?
Provide a short and direct response. 0.99. What is the ratio of the Electricity production(% of total) in South Africa in 1997 to that in 1999?
Offer a terse response. 1. What is the ratio of the Electricity production(% of total) of Sweden in 1997 to that in 1999?
Ensure brevity in your answer.  0.91. What is the ratio of the Electricity production(% of total) of Russian Federation in 1998 to that in 1999?
Your response must be concise. 1.03. What is the ratio of the Electricity production(% of total) in Sweden in 1998 to that in 1999?
Your answer should be very brief. 0.93. What is the difference between the highest and the second highest Electricity production(% of total) in Norway?
Your answer should be compact. 0. What is the difference between the highest and the second highest Electricity production(% of total) of Russian Federation?
Your answer should be very brief. 0.55. What is the difference between the highest and the second highest Electricity production(% of total) of South Africa?
Offer a very short reply. 1.87. What is the difference between the highest and the second highest Electricity production(% of total) of Sweden?
Provide a short and direct response. 0.86. What is the difference between the highest and the lowest Electricity production(% of total) of Norway?
Make the answer very short. 0.02. What is the difference between the highest and the lowest Electricity production(% of total) in Russian Federation?
Offer a very short reply. 4.07. What is the difference between the highest and the lowest Electricity production(% of total) in South Africa?
Your answer should be very brief. 3.33. What is the difference between the highest and the lowest Electricity production(% of total) of Sweden?
Your answer should be very brief. 1.23. 